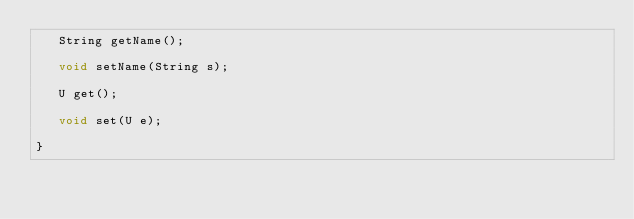<code> <loc_0><loc_0><loc_500><loc_500><_Java_>	 String getName();

	 void setName(String s);

	 U get();

	 void set(U e);

}
</code> 